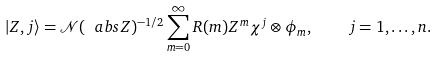<formula> <loc_0><loc_0><loc_500><loc_500>| Z , j \rangle = \mathcal { N } ( \ a b s { Z } ) ^ { - 1 / 2 } \sum _ { m = 0 } ^ { \infty } R ( m ) Z ^ { m } \chi ^ { j } \otimes \phi _ { m } , \quad j = 1 , \dots , n .</formula> 